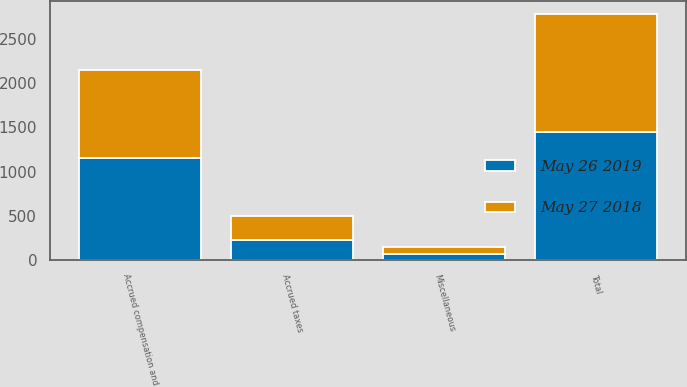<chart> <loc_0><loc_0><loc_500><loc_500><stacked_bar_chart><ecel><fcel>Accrued compensation and<fcel>Accrued taxes<fcel>Miscellaneous<fcel>Total<nl><fcel>May 26 2019<fcel>1153.3<fcel>227.1<fcel>68.5<fcel>1448.9<nl><fcel>May 27 2018<fcel>999.4<fcel>265.3<fcel>76.3<fcel>1341<nl></chart> 